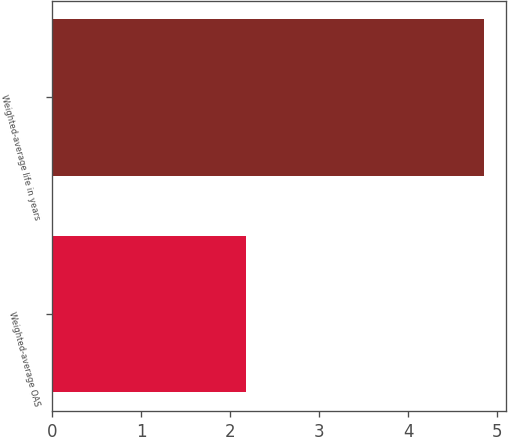Convert chart to OTSL. <chart><loc_0><loc_0><loc_500><loc_500><bar_chart><fcel>Weighted-average OAS<fcel>Weighted-average life in years<nl><fcel>2.17<fcel>4.85<nl></chart> 